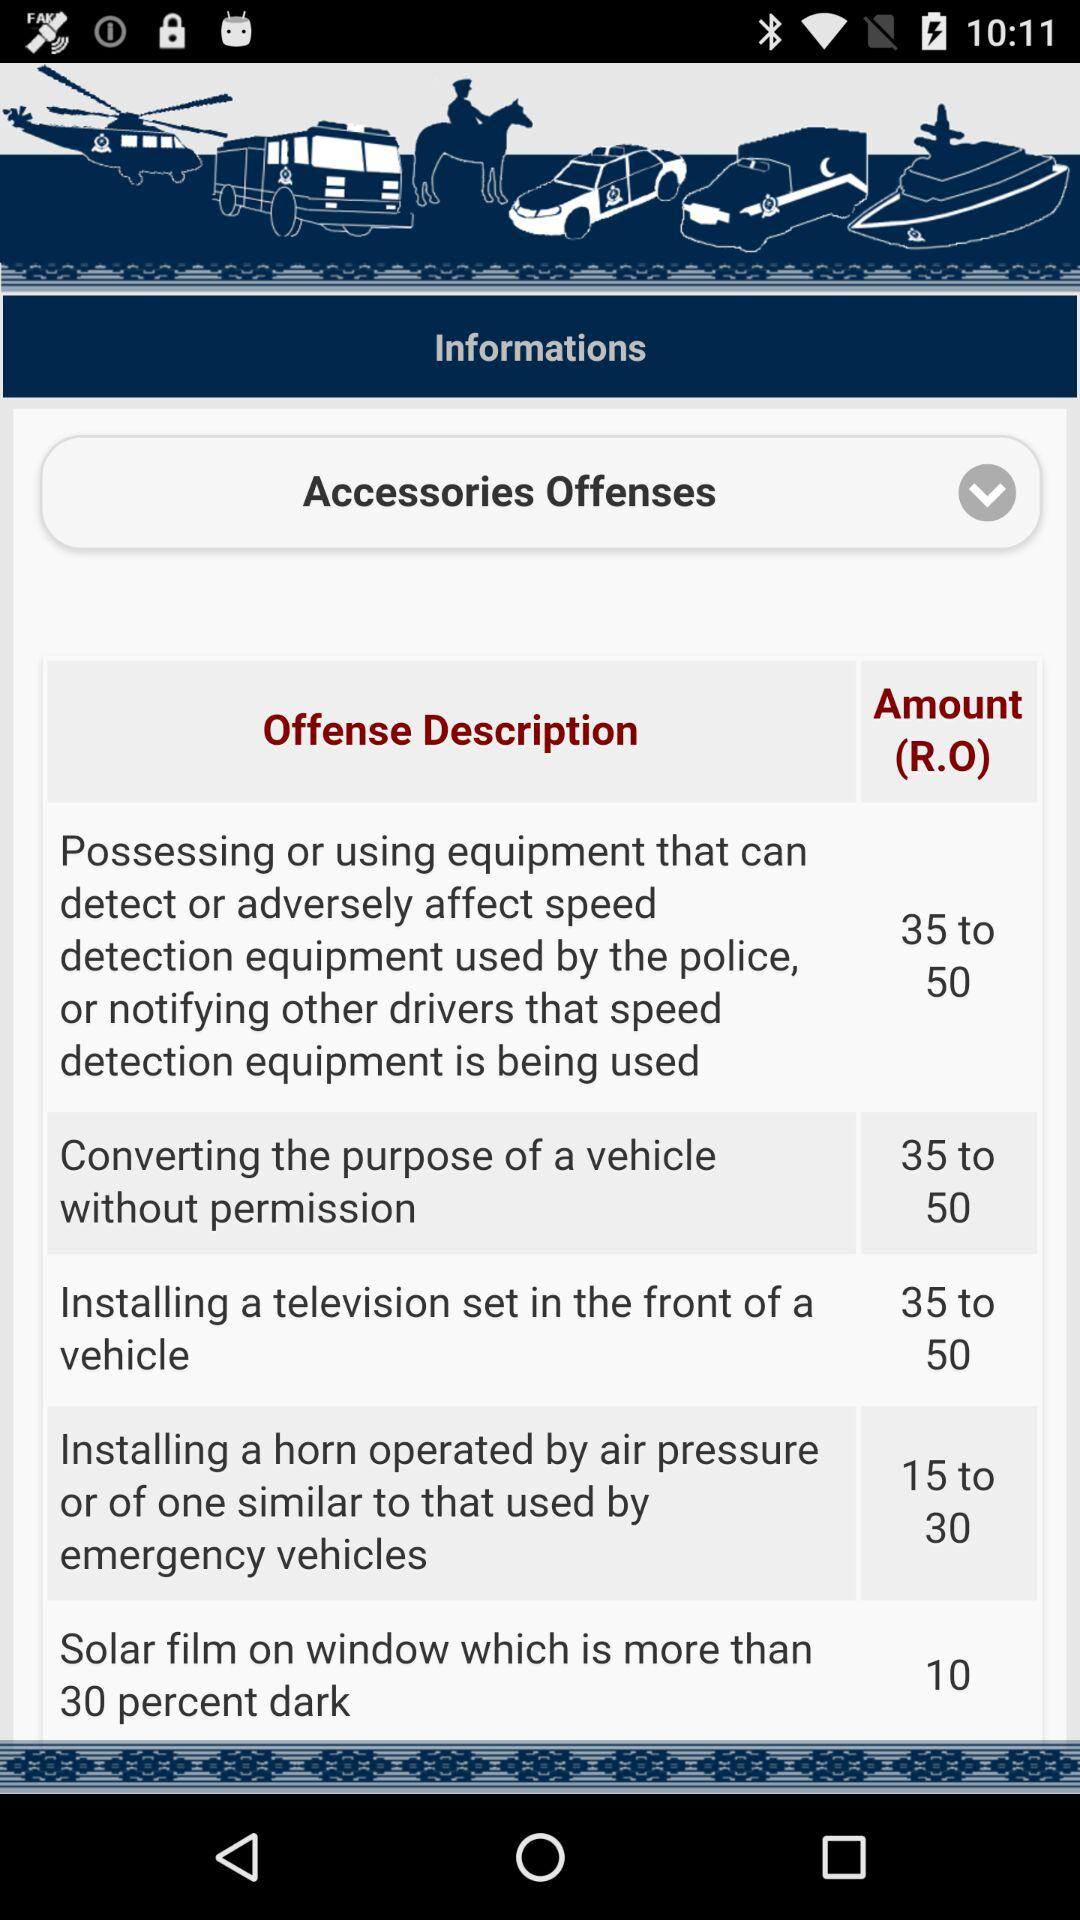What is the cost range of installing a television set in the front of a vehicle? The cost ranges between 35 and 50 RO. 